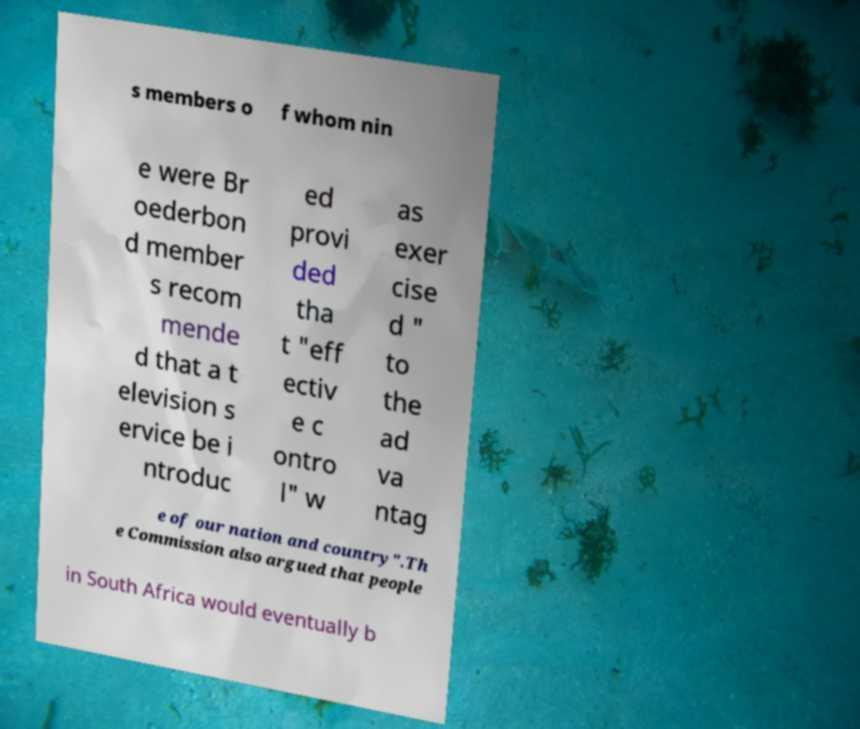There's text embedded in this image that I need extracted. Can you transcribe it verbatim? s members o f whom nin e were Br oederbon d member s recom mende d that a t elevision s ervice be i ntroduc ed provi ded tha t "eff ectiv e c ontro l" w as exer cise d " to the ad va ntag e of our nation and country".Th e Commission also argued that people in South Africa would eventually b 